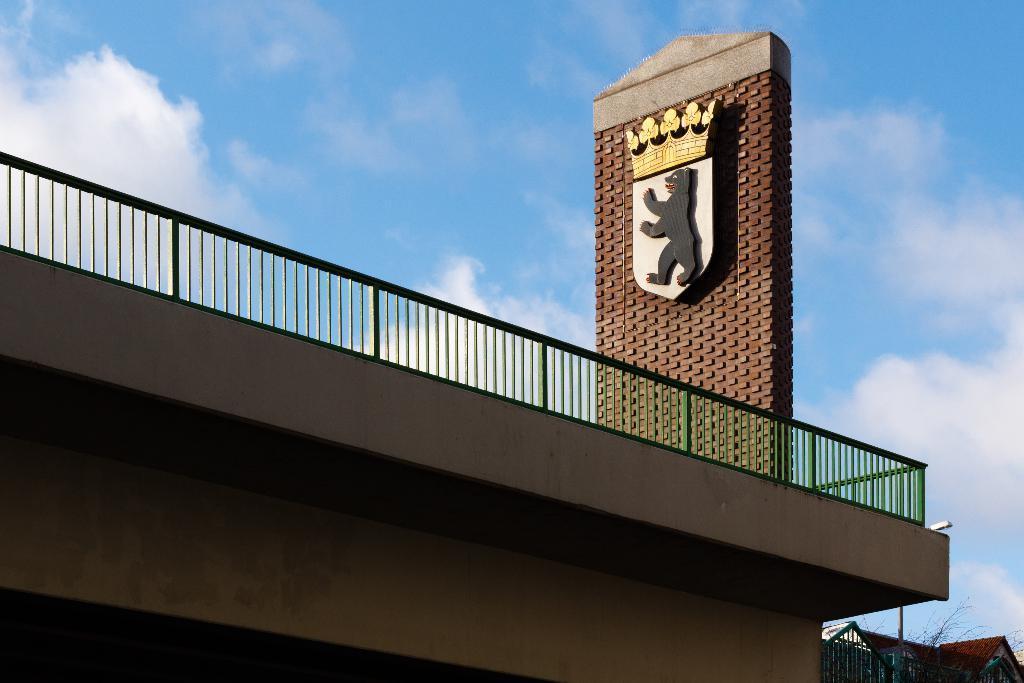Please provide a concise description of this image. In the picture we can see a building on the top of it, we can see a railing and on it we can see a wall with a bear sculpture on it and off it, we can see a crown, and inside the building we can see some houses and some dried tree and a pole and in the background we can see a sky with clouds. 